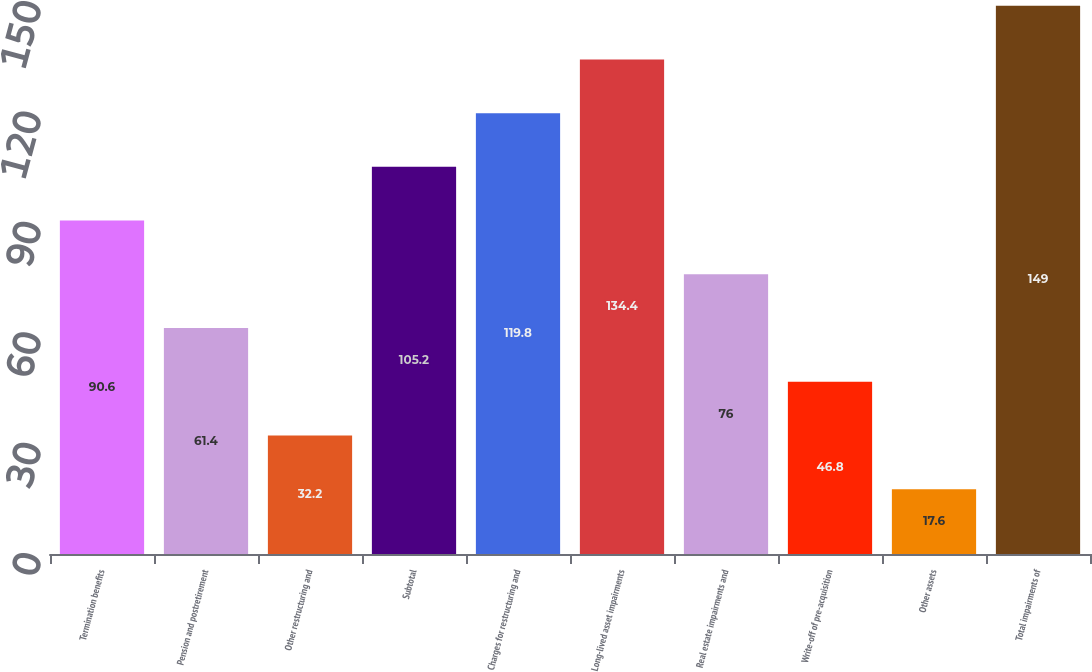Convert chart to OTSL. <chart><loc_0><loc_0><loc_500><loc_500><bar_chart><fcel>Termination benefits<fcel>Pension and postretirement<fcel>Other restructuring and<fcel>Subtotal<fcel>Charges for restructuring and<fcel>Long-lived asset impairments<fcel>Real estate impairments and<fcel>Write-off of pre-acquisition<fcel>Other assets<fcel>Total impairments of<nl><fcel>90.6<fcel>61.4<fcel>32.2<fcel>105.2<fcel>119.8<fcel>134.4<fcel>76<fcel>46.8<fcel>17.6<fcel>149<nl></chart> 